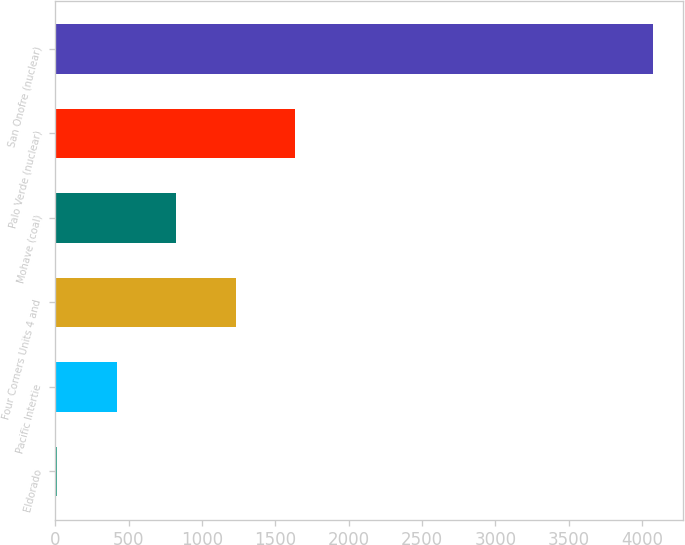Convert chart. <chart><loc_0><loc_0><loc_500><loc_500><bar_chart><fcel>Eldorado<fcel>Pacific Intertie<fcel>Four Corners Units 4 and<fcel>Mohave (coal)<fcel>Palo Verde (nuclear)<fcel>San Onofre (nuclear)<nl><fcel>13<fcel>419.2<fcel>1231.6<fcel>825.4<fcel>1637.8<fcel>4075<nl></chart> 